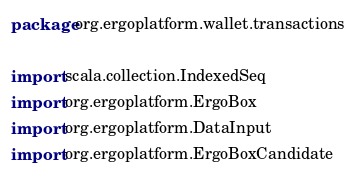<code> <loc_0><loc_0><loc_500><loc_500><_Scala_>package org.ergoplatform.wallet.transactions

import scala.collection.IndexedSeq
import org.ergoplatform.ErgoBox
import org.ergoplatform.DataInput
import org.ergoplatform.ErgoBoxCandidate</code> 